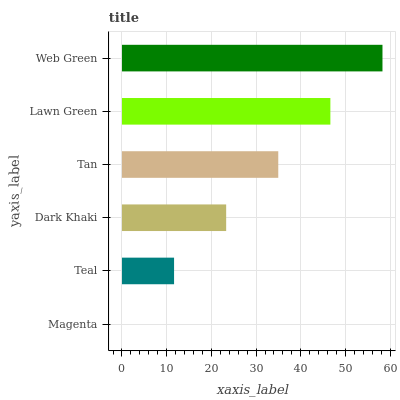Is Magenta the minimum?
Answer yes or no. Yes. Is Web Green the maximum?
Answer yes or no. Yes. Is Teal the minimum?
Answer yes or no. No. Is Teal the maximum?
Answer yes or no. No. Is Teal greater than Magenta?
Answer yes or no. Yes. Is Magenta less than Teal?
Answer yes or no. Yes. Is Magenta greater than Teal?
Answer yes or no. No. Is Teal less than Magenta?
Answer yes or no. No. Is Tan the high median?
Answer yes or no. Yes. Is Dark Khaki the low median?
Answer yes or no. Yes. Is Dark Khaki the high median?
Answer yes or no. No. Is Magenta the low median?
Answer yes or no. No. 